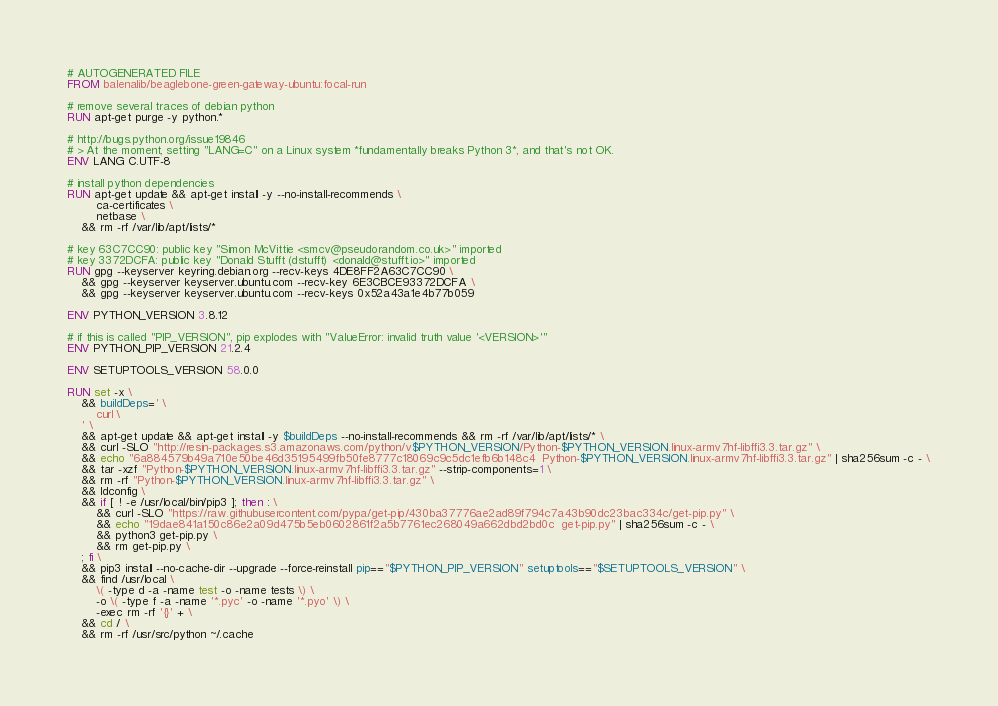<code> <loc_0><loc_0><loc_500><loc_500><_Dockerfile_># AUTOGENERATED FILE
FROM balenalib/beaglebone-green-gateway-ubuntu:focal-run

# remove several traces of debian python
RUN apt-get purge -y python.*

# http://bugs.python.org/issue19846
# > At the moment, setting "LANG=C" on a Linux system *fundamentally breaks Python 3*, and that's not OK.
ENV LANG C.UTF-8

# install python dependencies
RUN apt-get update && apt-get install -y --no-install-recommends \
		ca-certificates \
		netbase \
	&& rm -rf /var/lib/apt/lists/*

# key 63C7CC90: public key "Simon McVittie <smcv@pseudorandom.co.uk>" imported
# key 3372DCFA: public key "Donald Stufft (dstufft) <donald@stufft.io>" imported
RUN gpg --keyserver keyring.debian.org --recv-keys 4DE8FF2A63C7CC90 \
	&& gpg --keyserver keyserver.ubuntu.com --recv-key 6E3CBCE93372DCFA \
	&& gpg --keyserver keyserver.ubuntu.com --recv-keys 0x52a43a1e4b77b059

ENV PYTHON_VERSION 3.8.12

# if this is called "PIP_VERSION", pip explodes with "ValueError: invalid truth value '<VERSION>'"
ENV PYTHON_PIP_VERSION 21.2.4

ENV SETUPTOOLS_VERSION 58.0.0

RUN set -x \
	&& buildDeps=' \
		curl \
	' \
	&& apt-get update && apt-get install -y $buildDeps --no-install-recommends && rm -rf /var/lib/apt/lists/* \
	&& curl -SLO "http://resin-packages.s3.amazonaws.com/python/v$PYTHON_VERSION/Python-$PYTHON_VERSION.linux-armv7hf-libffi3.3.tar.gz" \
	&& echo "6a884579b49a710e50be46d35195499fb50fe8777c18069c9c5dc1efb6b148c4  Python-$PYTHON_VERSION.linux-armv7hf-libffi3.3.tar.gz" | sha256sum -c - \
	&& tar -xzf "Python-$PYTHON_VERSION.linux-armv7hf-libffi3.3.tar.gz" --strip-components=1 \
	&& rm -rf "Python-$PYTHON_VERSION.linux-armv7hf-libffi3.3.tar.gz" \
	&& ldconfig \
	&& if [ ! -e /usr/local/bin/pip3 ]; then : \
		&& curl -SLO "https://raw.githubusercontent.com/pypa/get-pip/430ba37776ae2ad89f794c7a43b90dc23bac334c/get-pip.py" \
		&& echo "19dae841a150c86e2a09d475b5eb0602861f2a5b7761ec268049a662dbd2bd0c  get-pip.py" | sha256sum -c - \
		&& python3 get-pip.py \
		&& rm get-pip.py \
	; fi \
	&& pip3 install --no-cache-dir --upgrade --force-reinstall pip=="$PYTHON_PIP_VERSION" setuptools=="$SETUPTOOLS_VERSION" \
	&& find /usr/local \
		\( -type d -a -name test -o -name tests \) \
		-o \( -type f -a -name '*.pyc' -o -name '*.pyo' \) \
		-exec rm -rf '{}' + \
	&& cd / \
	&& rm -rf /usr/src/python ~/.cache
</code> 